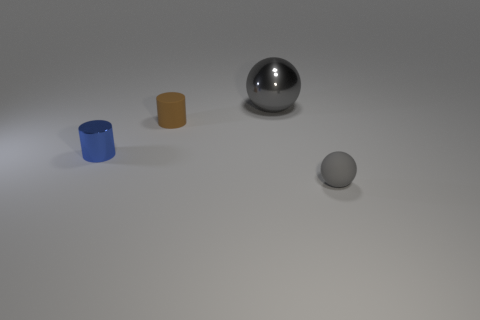Add 1 large gray spheres. How many objects exist? 5 Subtract all brown cylinders. Subtract all purple blocks. How many cylinders are left? 1 Subtract all green cubes. How many brown cylinders are left? 1 Subtract all tiny cylinders. Subtract all blue shiny things. How many objects are left? 1 Add 4 big objects. How many big objects are left? 5 Add 3 brown spheres. How many brown spheres exist? 3 Subtract 0 gray cylinders. How many objects are left? 4 Subtract 2 cylinders. How many cylinders are left? 0 